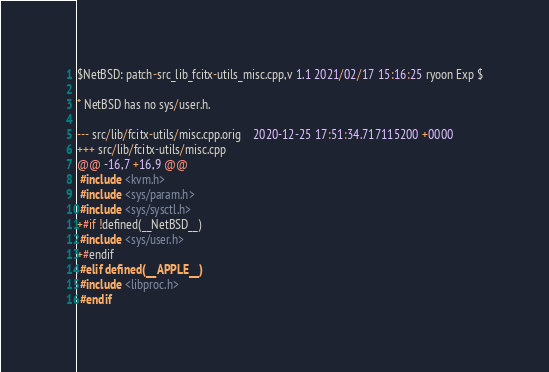Convert code to text. <code><loc_0><loc_0><loc_500><loc_500><_C++_>$NetBSD: patch-src_lib_fcitx-utils_misc.cpp,v 1.1 2021/02/17 15:16:25 ryoon Exp $

* NetBSD has no sys/user.h.

--- src/lib/fcitx-utils/misc.cpp.orig	2020-12-25 17:51:34.717115200 +0000
+++ src/lib/fcitx-utils/misc.cpp
@@ -16,7 +16,9 @@
 #include <kvm.h>
 #include <sys/param.h>
 #include <sys/sysctl.h>
+#if !defined(__NetBSD__)
 #include <sys/user.h>
+#endif
 #elif defined(__APPLE__)
 #include <libproc.h>
 #endif
</code> 